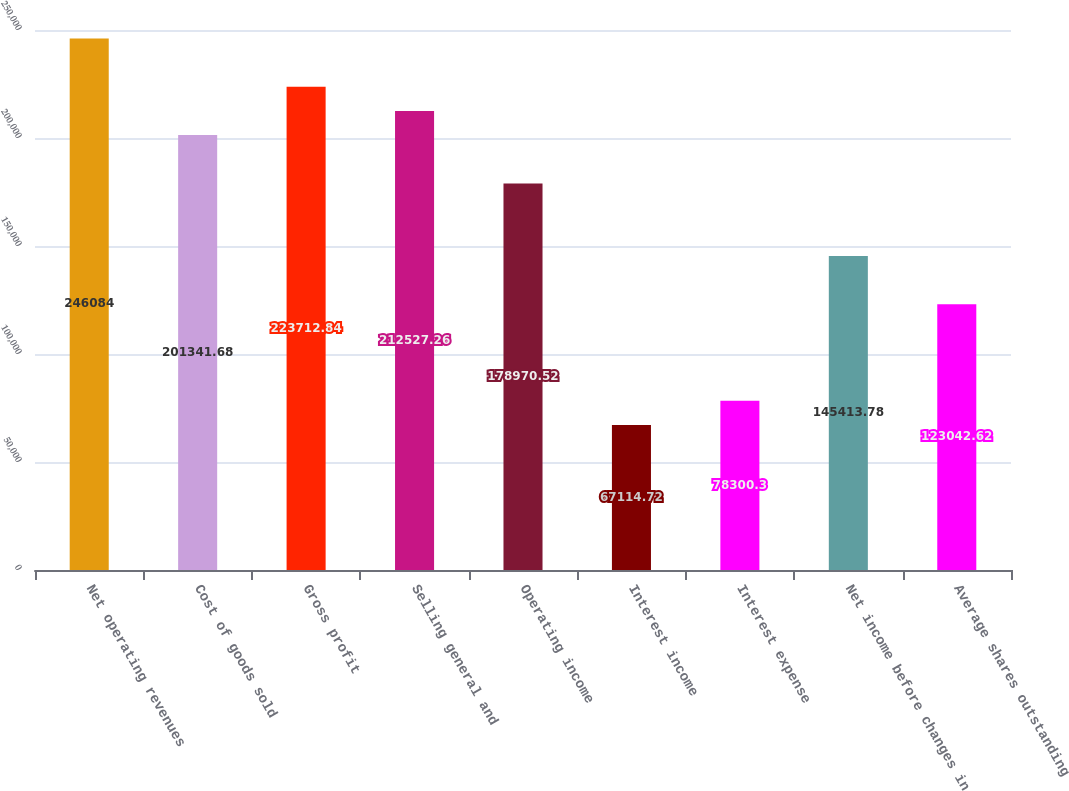Convert chart. <chart><loc_0><loc_0><loc_500><loc_500><bar_chart><fcel>Net operating revenues<fcel>Cost of goods sold<fcel>Gross profit<fcel>Selling general and<fcel>Operating income<fcel>Interest income<fcel>Interest expense<fcel>Net income before changes in<fcel>Average shares outstanding<nl><fcel>246084<fcel>201342<fcel>223713<fcel>212527<fcel>178971<fcel>67114.7<fcel>78300.3<fcel>145414<fcel>123043<nl></chart> 